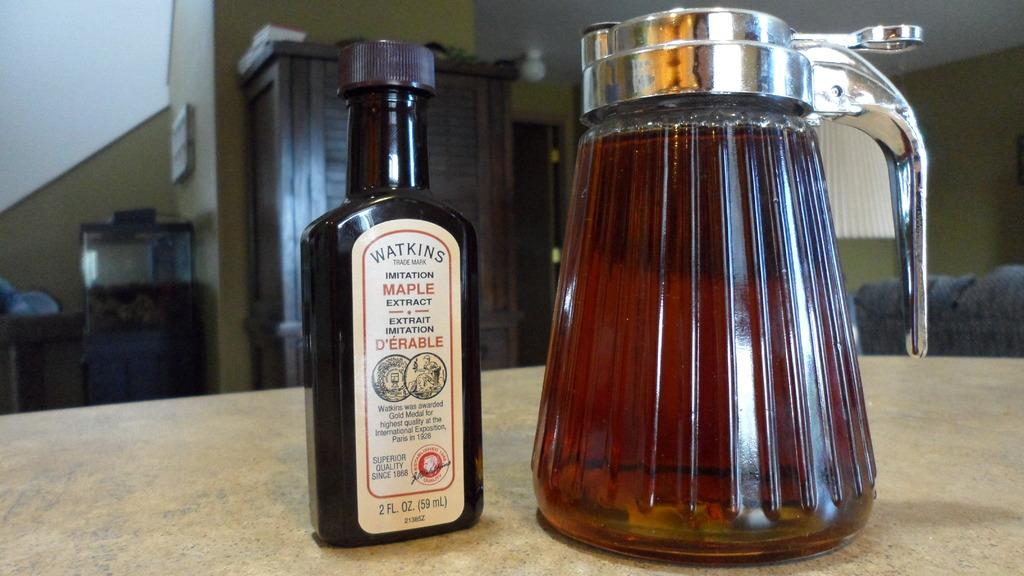<image>
Summarize the visual content of the image. A bottle with the brand name Watkins is on a bottle of maple extract. 